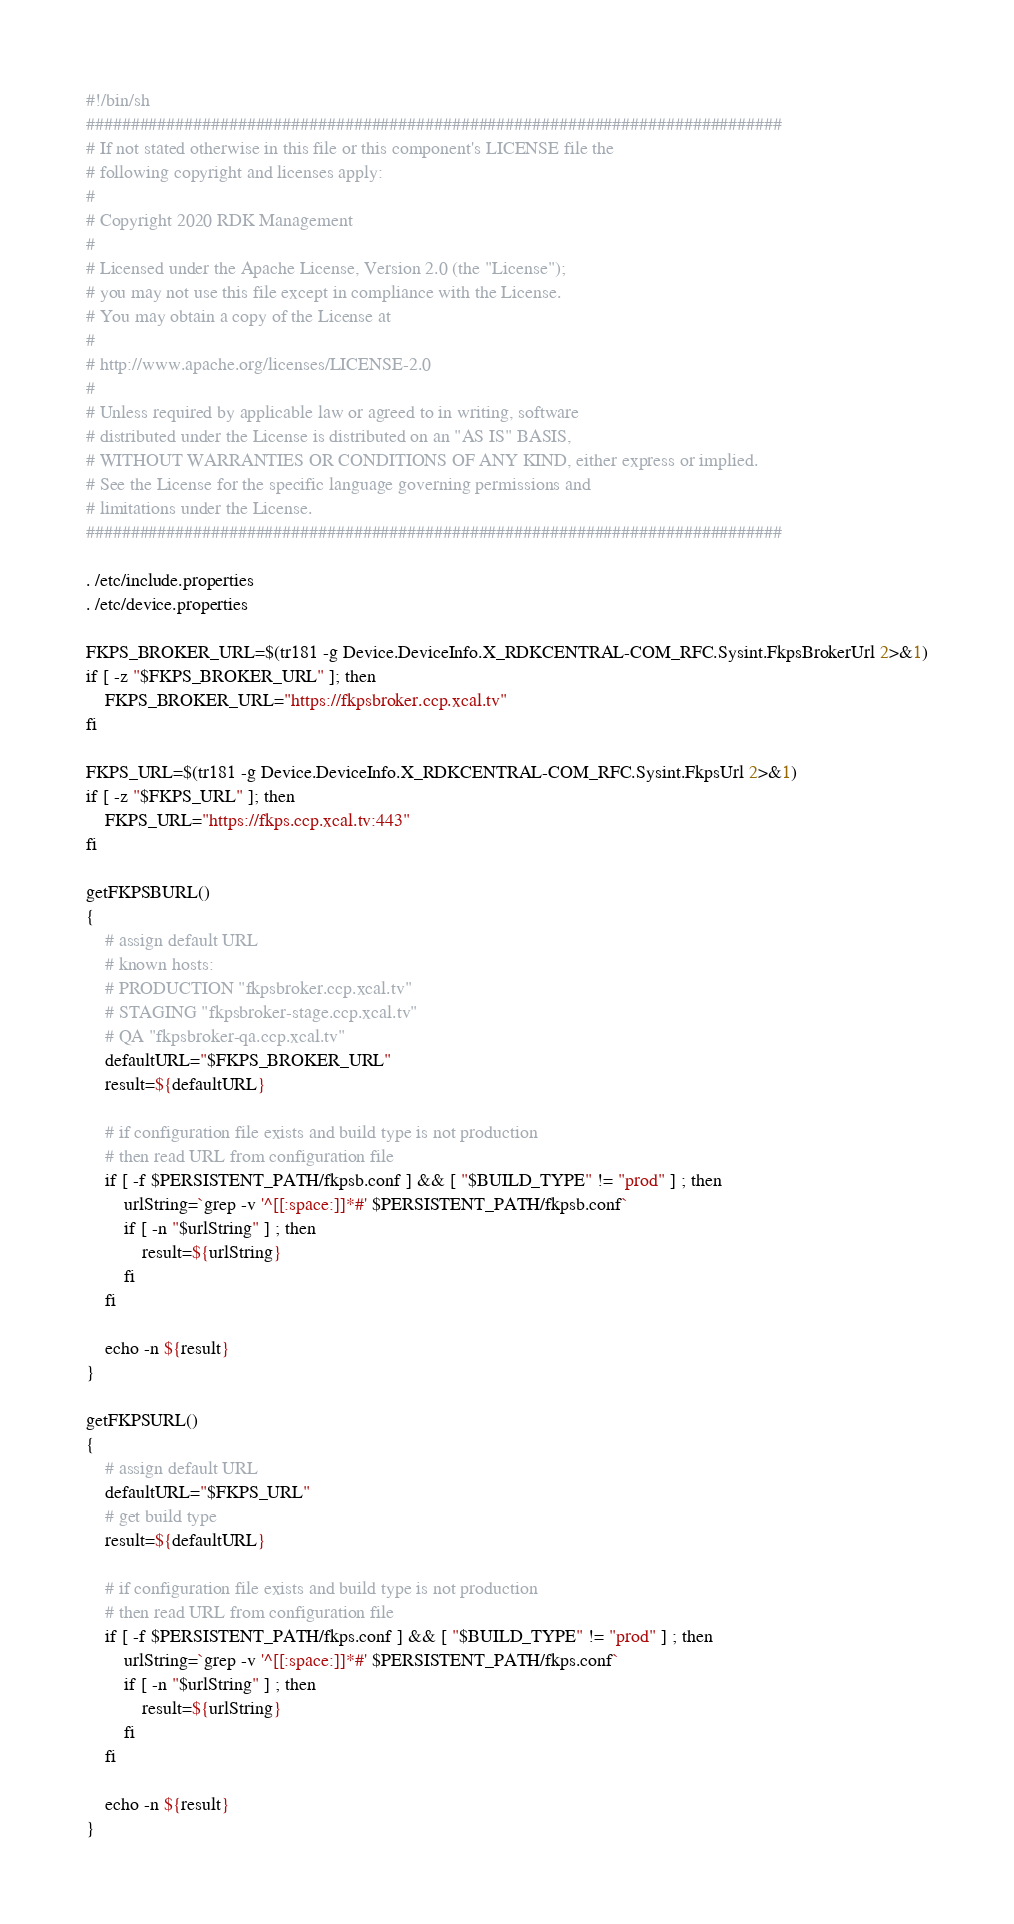Convert code to text. <code><loc_0><loc_0><loc_500><loc_500><_Bash_>#!/bin/sh
##############################################################################
# If not stated otherwise in this file or this component's LICENSE file the
# following copyright and licenses apply:
#
# Copyright 2020 RDK Management
#
# Licensed under the Apache License, Version 2.0 (the "License");
# you may not use this file except in compliance with the License.
# You may obtain a copy of the License at
#
# http://www.apache.org/licenses/LICENSE-2.0
#
# Unless required by applicable law or agreed to in writing, software
# distributed under the License is distributed on an "AS IS" BASIS,
# WITHOUT WARRANTIES OR CONDITIONS OF ANY KIND, either express or implied.
# See the License for the specific language governing permissions and
# limitations under the License.
##############################################################################

. /etc/include.properties
. /etc/device.properties

FKPS_BROKER_URL=$(tr181 -g Device.DeviceInfo.X_RDKCENTRAL-COM_RFC.Sysint.FkpsBrokerUrl 2>&1)
if [ -z "$FKPS_BROKER_URL" ]; then
    FKPS_BROKER_URL="https://fkpsbroker.ccp.xcal.tv"
fi

FKPS_URL=$(tr181 -g Device.DeviceInfo.X_RDKCENTRAL-COM_RFC.Sysint.FkpsUrl 2>&1)
if [ -z "$FKPS_URL" ]; then
    FKPS_URL="https://fkps.ccp.xcal.tv:443"
fi

getFKPSBURL()
{
    # assign default URL
    # known hosts:
    # PRODUCTION "fkpsbroker.ccp.xcal.tv"
    # STAGING "fkpsbroker-stage.ccp.xcal.tv"
    # QA "fkpsbroker-qa.ccp.xcal.tv"
    defaultURL="$FKPS_BROKER_URL"
    result=${defaultURL}

    # if configuration file exists and build type is not production
    # then read URL from configuration file
    if [ -f $PERSISTENT_PATH/fkpsb.conf ] && [ "$BUILD_TYPE" != "prod" ] ; then
        urlString=`grep -v '^[[:space:]]*#' $PERSISTENT_PATH/fkpsb.conf`
        if [ -n "$urlString" ] ; then
            result=${urlString}
        fi
    fi

    echo -n ${result}
}

getFKPSURL()
{
    # assign default URL
    defaultURL="$FKPS_URL"
    # get build type
    result=${defaultURL}

    # if configuration file exists and build type is not production
    # then read URL from configuration file
    if [ -f $PERSISTENT_PATH/fkps.conf ] && [ "$BUILD_TYPE" != "prod" ] ; then
        urlString=`grep -v '^[[:space:]]*#' $PERSISTENT_PATH/fkps.conf`
        if [ -n "$urlString" ] ; then
            result=${urlString}
        fi
    fi

    echo -n ${result}
}
</code> 